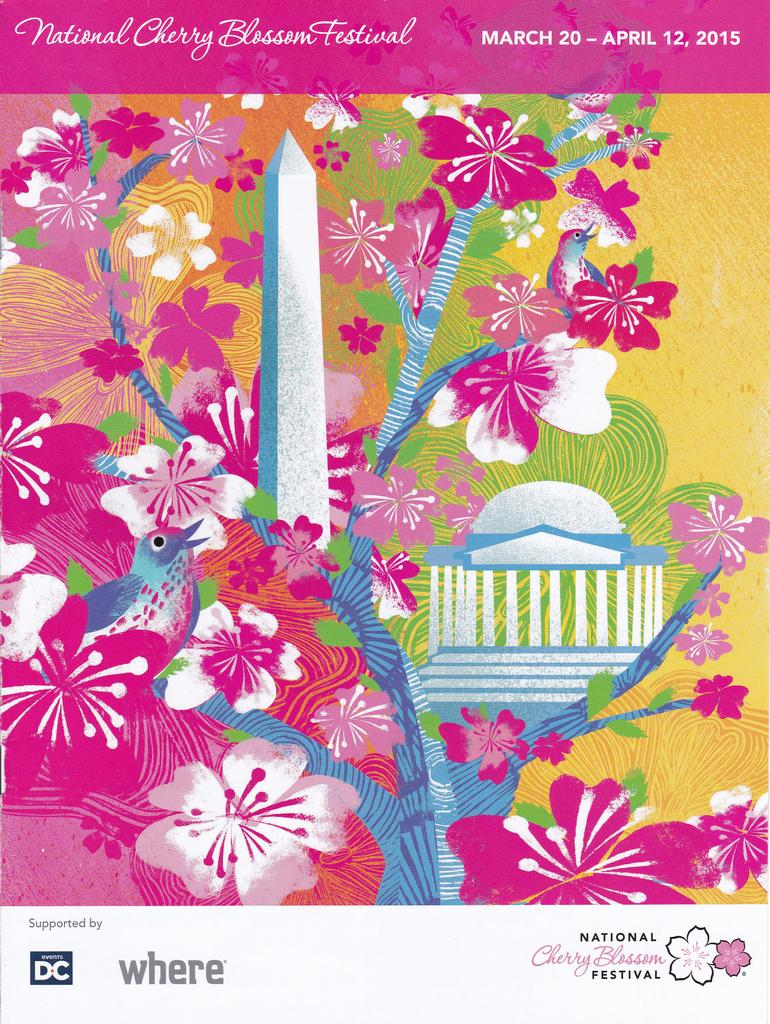What is the main subject of the image? The main subject of the image is a poster. What type of images are on the poster? The poster has images of flowers and a bird. Are there any words on the poster? Yes, there is text on the poster. How many pans are visible in the image? There are no pans present in the image; it features a poster with images of flowers and a bird, along with text. Can you describe the man in the image? There is no man present in the image; it only contains a poster with images of flowers, a bird, and text. 